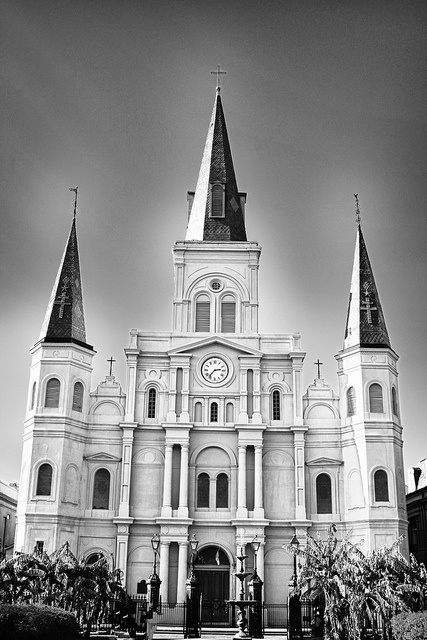Describe the objects in this image and their specific colors. I can see a clock in gray, white, darkgray, and black tones in this image. 